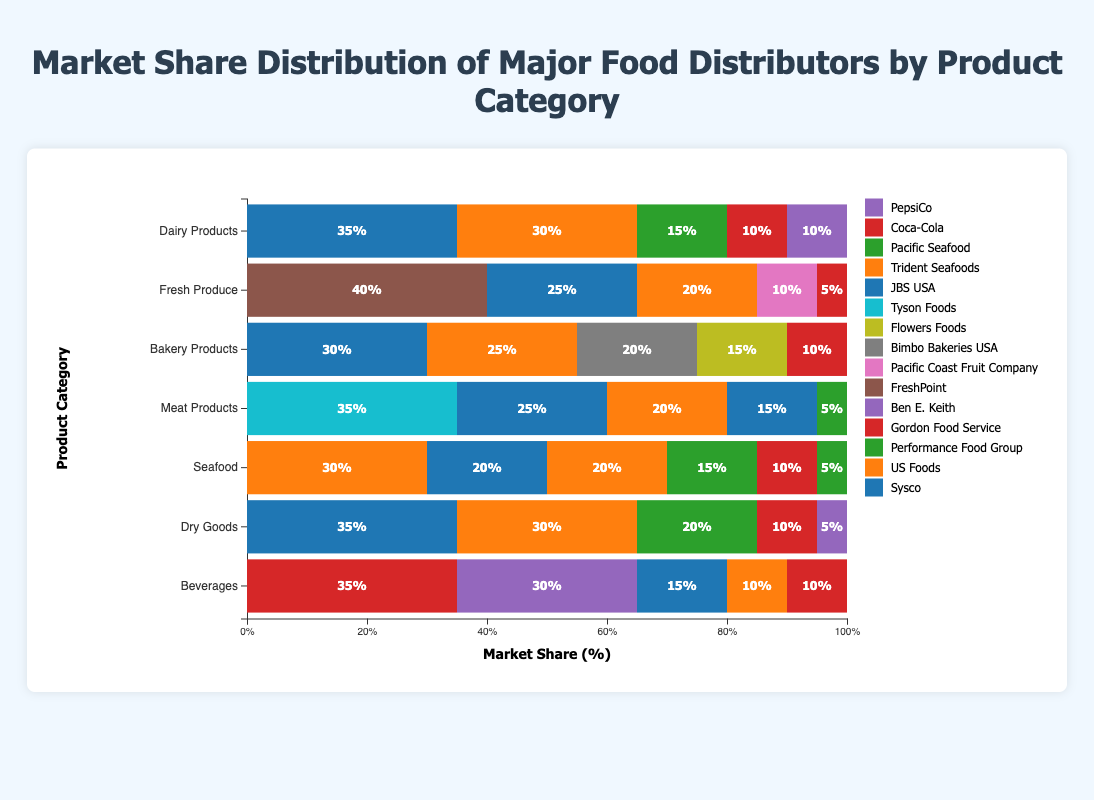Which distributor has the highest market share for Dairy Products? In the Dairy Products category, Sysco has a market share of 35%, which is the highest compared to others.
Answer: Sysco How does US Foods' market share in Fresh Produce compare to its market share in Dairy Products? US Foods has a 20% market share in Fresh Produce and a 30% market share in Dairy Products. The market share in Dairy Products is higher by 10%.
Answer: Dairy Products by 10% Which product category does Gordon Food Service have the highest market share? By observing all product categories, Gordon Food Service has the highest market share in Dairy Products, which is 10%.
Answer: Dairy Products What is the combined market share of US Foods and Sysco for Bakery Products? US Foods has a 25% market share and Sysco has a 30% market share in Bakery Products. Combined, their share is 25% + 30% = 55%.
Answer: 55% Which distributor is unique to the Fresh Produce category but does not appear in other categories? FreshPoint is unique to the Fresh Produce category and is not listed in any other categories.
Answer: FreshPoint Which distributor shows up in all product categories displayed? Sysco appears in every product category (Dairy Products, Fresh Produce, Bakery Products, Meat Products, Seafood, Dry Goods, Beverages).
Answer: Sysco How many product categories does Performance Food Group participate in, and what's the total of their combined market share across these categories? Performance Food Group participates in Dairy Products (15%), Meat Products (5%), Seafood (15%), and Dry Goods (20%). Summing these up: 15 + 5 + 15 + 20 = 55%.
Answer: 4 categories, 55% Which product category has the least market share variance among the distributors? By comparing the range of market shares, Dairy Products has the least variance (35% - 10% = 25%) compared to other categories.
Answer: Dairy Products 